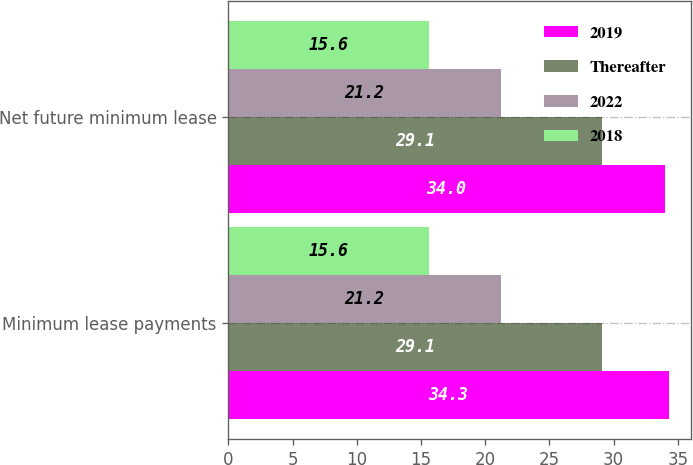<chart> <loc_0><loc_0><loc_500><loc_500><stacked_bar_chart><ecel><fcel>Minimum lease payments<fcel>Net future minimum lease<nl><fcel>2019<fcel>34.3<fcel>34<nl><fcel>Thereafter<fcel>29.1<fcel>29.1<nl><fcel>2022<fcel>21.2<fcel>21.2<nl><fcel>2018<fcel>15.6<fcel>15.6<nl></chart> 